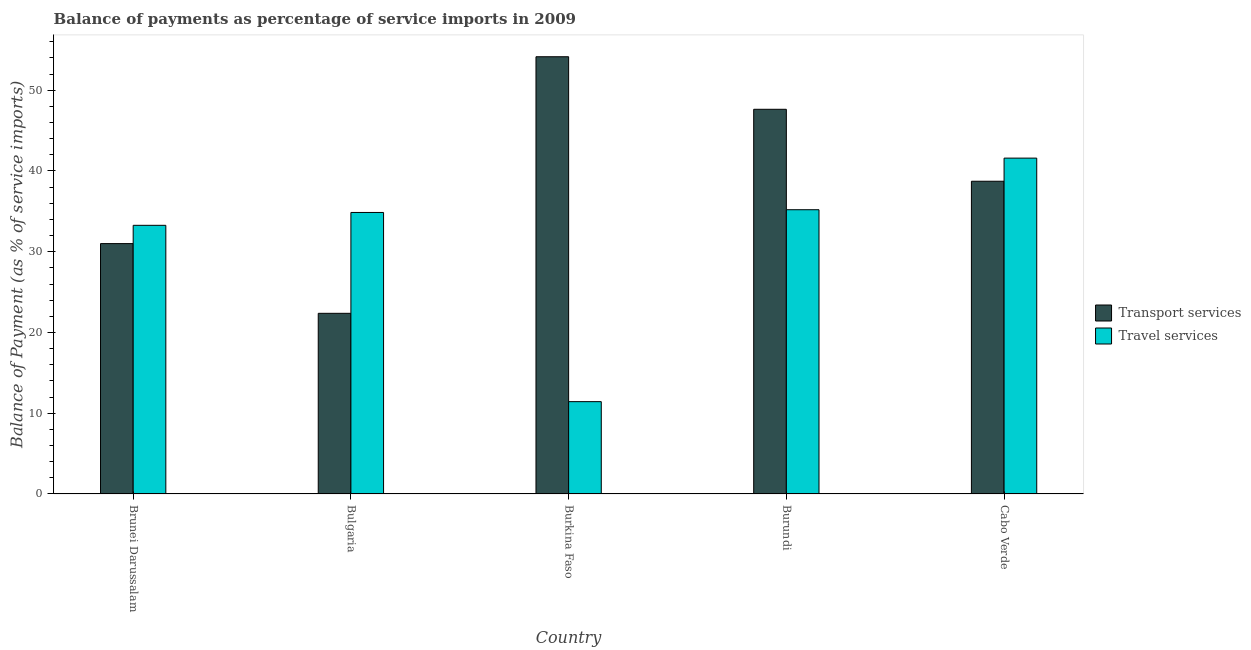How many different coloured bars are there?
Keep it short and to the point. 2. What is the label of the 1st group of bars from the left?
Ensure brevity in your answer.  Brunei Darussalam. In how many cases, is the number of bars for a given country not equal to the number of legend labels?
Provide a succinct answer. 0. What is the balance of payments of travel services in Bulgaria?
Your response must be concise. 34.86. Across all countries, what is the maximum balance of payments of travel services?
Provide a succinct answer. 41.59. Across all countries, what is the minimum balance of payments of transport services?
Keep it short and to the point. 22.37. In which country was the balance of payments of travel services maximum?
Your answer should be compact. Cabo Verde. In which country was the balance of payments of travel services minimum?
Offer a terse response. Burkina Faso. What is the total balance of payments of travel services in the graph?
Provide a succinct answer. 156.35. What is the difference between the balance of payments of travel services in Bulgaria and that in Burkina Faso?
Keep it short and to the point. 23.43. What is the difference between the balance of payments of travel services in Brunei Darussalam and the balance of payments of transport services in Burundi?
Offer a terse response. -14.37. What is the average balance of payments of travel services per country?
Keep it short and to the point. 31.27. What is the difference between the balance of payments of travel services and balance of payments of transport services in Burundi?
Make the answer very short. -12.44. In how many countries, is the balance of payments of transport services greater than 40 %?
Make the answer very short. 2. What is the ratio of the balance of payments of travel services in Bulgaria to that in Burkina Faso?
Ensure brevity in your answer.  3.05. Is the balance of payments of transport services in Burkina Faso less than that in Burundi?
Provide a succinct answer. No. Is the difference between the balance of payments of transport services in Bulgaria and Burkina Faso greater than the difference between the balance of payments of travel services in Bulgaria and Burkina Faso?
Your answer should be very brief. No. What is the difference between the highest and the second highest balance of payments of travel services?
Ensure brevity in your answer.  6.39. What is the difference between the highest and the lowest balance of payments of transport services?
Make the answer very short. 31.77. What does the 1st bar from the left in Burundi represents?
Make the answer very short. Transport services. What does the 1st bar from the right in Cabo Verde represents?
Provide a short and direct response. Travel services. Are all the bars in the graph horizontal?
Offer a terse response. No. Does the graph contain grids?
Your answer should be compact. No. Where does the legend appear in the graph?
Make the answer very short. Center right. What is the title of the graph?
Your answer should be compact. Balance of payments as percentage of service imports in 2009. Does "Transport services" appear as one of the legend labels in the graph?
Give a very brief answer. Yes. What is the label or title of the X-axis?
Provide a succinct answer. Country. What is the label or title of the Y-axis?
Keep it short and to the point. Balance of Payment (as % of service imports). What is the Balance of Payment (as % of service imports) in Transport services in Brunei Darussalam?
Give a very brief answer. 31. What is the Balance of Payment (as % of service imports) in Travel services in Brunei Darussalam?
Your answer should be compact. 33.27. What is the Balance of Payment (as % of service imports) in Transport services in Bulgaria?
Give a very brief answer. 22.37. What is the Balance of Payment (as % of service imports) of Travel services in Bulgaria?
Give a very brief answer. 34.86. What is the Balance of Payment (as % of service imports) of Transport services in Burkina Faso?
Your answer should be compact. 54.15. What is the Balance of Payment (as % of service imports) in Travel services in Burkina Faso?
Make the answer very short. 11.43. What is the Balance of Payment (as % of service imports) in Transport services in Burundi?
Keep it short and to the point. 47.64. What is the Balance of Payment (as % of service imports) in Travel services in Burundi?
Offer a very short reply. 35.2. What is the Balance of Payment (as % of service imports) of Transport services in Cabo Verde?
Ensure brevity in your answer.  38.73. What is the Balance of Payment (as % of service imports) in Travel services in Cabo Verde?
Your answer should be very brief. 41.59. Across all countries, what is the maximum Balance of Payment (as % of service imports) of Transport services?
Provide a succinct answer. 54.15. Across all countries, what is the maximum Balance of Payment (as % of service imports) in Travel services?
Provide a succinct answer. 41.59. Across all countries, what is the minimum Balance of Payment (as % of service imports) in Transport services?
Offer a very short reply. 22.37. Across all countries, what is the minimum Balance of Payment (as % of service imports) of Travel services?
Your answer should be very brief. 11.43. What is the total Balance of Payment (as % of service imports) in Transport services in the graph?
Offer a terse response. 193.89. What is the total Balance of Payment (as % of service imports) in Travel services in the graph?
Provide a succinct answer. 156.35. What is the difference between the Balance of Payment (as % of service imports) of Transport services in Brunei Darussalam and that in Bulgaria?
Offer a very short reply. 8.63. What is the difference between the Balance of Payment (as % of service imports) of Travel services in Brunei Darussalam and that in Bulgaria?
Provide a succinct answer. -1.59. What is the difference between the Balance of Payment (as % of service imports) of Transport services in Brunei Darussalam and that in Burkina Faso?
Provide a short and direct response. -23.14. What is the difference between the Balance of Payment (as % of service imports) in Travel services in Brunei Darussalam and that in Burkina Faso?
Provide a short and direct response. 21.83. What is the difference between the Balance of Payment (as % of service imports) in Transport services in Brunei Darussalam and that in Burundi?
Keep it short and to the point. -16.63. What is the difference between the Balance of Payment (as % of service imports) in Travel services in Brunei Darussalam and that in Burundi?
Your answer should be very brief. -1.93. What is the difference between the Balance of Payment (as % of service imports) in Transport services in Brunei Darussalam and that in Cabo Verde?
Your answer should be very brief. -7.72. What is the difference between the Balance of Payment (as % of service imports) of Travel services in Brunei Darussalam and that in Cabo Verde?
Your answer should be compact. -8.32. What is the difference between the Balance of Payment (as % of service imports) of Transport services in Bulgaria and that in Burkina Faso?
Your answer should be very brief. -31.77. What is the difference between the Balance of Payment (as % of service imports) of Travel services in Bulgaria and that in Burkina Faso?
Keep it short and to the point. 23.43. What is the difference between the Balance of Payment (as % of service imports) in Transport services in Bulgaria and that in Burundi?
Your answer should be very brief. -25.27. What is the difference between the Balance of Payment (as % of service imports) of Travel services in Bulgaria and that in Burundi?
Offer a very short reply. -0.34. What is the difference between the Balance of Payment (as % of service imports) of Transport services in Bulgaria and that in Cabo Verde?
Provide a short and direct response. -16.36. What is the difference between the Balance of Payment (as % of service imports) in Travel services in Bulgaria and that in Cabo Verde?
Make the answer very short. -6.73. What is the difference between the Balance of Payment (as % of service imports) in Transport services in Burkina Faso and that in Burundi?
Offer a very short reply. 6.51. What is the difference between the Balance of Payment (as % of service imports) of Travel services in Burkina Faso and that in Burundi?
Provide a succinct answer. -23.77. What is the difference between the Balance of Payment (as % of service imports) of Transport services in Burkina Faso and that in Cabo Verde?
Your response must be concise. 15.42. What is the difference between the Balance of Payment (as % of service imports) in Travel services in Burkina Faso and that in Cabo Verde?
Offer a very short reply. -30.16. What is the difference between the Balance of Payment (as % of service imports) of Transport services in Burundi and that in Cabo Verde?
Make the answer very short. 8.91. What is the difference between the Balance of Payment (as % of service imports) of Travel services in Burundi and that in Cabo Verde?
Keep it short and to the point. -6.39. What is the difference between the Balance of Payment (as % of service imports) in Transport services in Brunei Darussalam and the Balance of Payment (as % of service imports) in Travel services in Bulgaria?
Your response must be concise. -3.86. What is the difference between the Balance of Payment (as % of service imports) of Transport services in Brunei Darussalam and the Balance of Payment (as % of service imports) of Travel services in Burkina Faso?
Your response must be concise. 19.57. What is the difference between the Balance of Payment (as % of service imports) of Transport services in Brunei Darussalam and the Balance of Payment (as % of service imports) of Travel services in Burundi?
Your response must be concise. -4.2. What is the difference between the Balance of Payment (as % of service imports) of Transport services in Brunei Darussalam and the Balance of Payment (as % of service imports) of Travel services in Cabo Verde?
Give a very brief answer. -10.59. What is the difference between the Balance of Payment (as % of service imports) of Transport services in Bulgaria and the Balance of Payment (as % of service imports) of Travel services in Burkina Faso?
Provide a short and direct response. 10.94. What is the difference between the Balance of Payment (as % of service imports) in Transport services in Bulgaria and the Balance of Payment (as % of service imports) in Travel services in Burundi?
Offer a terse response. -12.83. What is the difference between the Balance of Payment (as % of service imports) of Transport services in Bulgaria and the Balance of Payment (as % of service imports) of Travel services in Cabo Verde?
Give a very brief answer. -19.22. What is the difference between the Balance of Payment (as % of service imports) of Transport services in Burkina Faso and the Balance of Payment (as % of service imports) of Travel services in Burundi?
Keep it short and to the point. 18.95. What is the difference between the Balance of Payment (as % of service imports) in Transport services in Burkina Faso and the Balance of Payment (as % of service imports) in Travel services in Cabo Verde?
Your response must be concise. 12.56. What is the difference between the Balance of Payment (as % of service imports) in Transport services in Burundi and the Balance of Payment (as % of service imports) in Travel services in Cabo Verde?
Your answer should be compact. 6.05. What is the average Balance of Payment (as % of service imports) of Transport services per country?
Offer a terse response. 38.78. What is the average Balance of Payment (as % of service imports) of Travel services per country?
Keep it short and to the point. 31.27. What is the difference between the Balance of Payment (as % of service imports) of Transport services and Balance of Payment (as % of service imports) of Travel services in Brunei Darussalam?
Provide a succinct answer. -2.26. What is the difference between the Balance of Payment (as % of service imports) in Transport services and Balance of Payment (as % of service imports) in Travel services in Bulgaria?
Keep it short and to the point. -12.49. What is the difference between the Balance of Payment (as % of service imports) in Transport services and Balance of Payment (as % of service imports) in Travel services in Burkina Faso?
Make the answer very short. 42.71. What is the difference between the Balance of Payment (as % of service imports) in Transport services and Balance of Payment (as % of service imports) in Travel services in Burundi?
Your response must be concise. 12.44. What is the difference between the Balance of Payment (as % of service imports) of Transport services and Balance of Payment (as % of service imports) of Travel services in Cabo Verde?
Your answer should be very brief. -2.86. What is the ratio of the Balance of Payment (as % of service imports) of Transport services in Brunei Darussalam to that in Bulgaria?
Give a very brief answer. 1.39. What is the ratio of the Balance of Payment (as % of service imports) of Travel services in Brunei Darussalam to that in Bulgaria?
Offer a very short reply. 0.95. What is the ratio of the Balance of Payment (as % of service imports) of Transport services in Brunei Darussalam to that in Burkina Faso?
Give a very brief answer. 0.57. What is the ratio of the Balance of Payment (as % of service imports) of Travel services in Brunei Darussalam to that in Burkina Faso?
Your answer should be compact. 2.91. What is the ratio of the Balance of Payment (as % of service imports) of Transport services in Brunei Darussalam to that in Burundi?
Your answer should be very brief. 0.65. What is the ratio of the Balance of Payment (as % of service imports) of Travel services in Brunei Darussalam to that in Burundi?
Your answer should be very brief. 0.95. What is the ratio of the Balance of Payment (as % of service imports) of Transport services in Brunei Darussalam to that in Cabo Verde?
Offer a very short reply. 0.8. What is the ratio of the Balance of Payment (as % of service imports) in Travel services in Brunei Darussalam to that in Cabo Verde?
Offer a terse response. 0.8. What is the ratio of the Balance of Payment (as % of service imports) in Transport services in Bulgaria to that in Burkina Faso?
Your answer should be very brief. 0.41. What is the ratio of the Balance of Payment (as % of service imports) of Travel services in Bulgaria to that in Burkina Faso?
Your answer should be compact. 3.05. What is the ratio of the Balance of Payment (as % of service imports) in Transport services in Bulgaria to that in Burundi?
Ensure brevity in your answer.  0.47. What is the ratio of the Balance of Payment (as % of service imports) of Travel services in Bulgaria to that in Burundi?
Ensure brevity in your answer.  0.99. What is the ratio of the Balance of Payment (as % of service imports) of Transport services in Bulgaria to that in Cabo Verde?
Offer a terse response. 0.58. What is the ratio of the Balance of Payment (as % of service imports) in Travel services in Bulgaria to that in Cabo Verde?
Keep it short and to the point. 0.84. What is the ratio of the Balance of Payment (as % of service imports) in Transport services in Burkina Faso to that in Burundi?
Offer a terse response. 1.14. What is the ratio of the Balance of Payment (as % of service imports) of Travel services in Burkina Faso to that in Burundi?
Offer a very short reply. 0.32. What is the ratio of the Balance of Payment (as % of service imports) in Transport services in Burkina Faso to that in Cabo Verde?
Your answer should be compact. 1.4. What is the ratio of the Balance of Payment (as % of service imports) in Travel services in Burkina Faso to that in Cabo Verde?
Provide a short and direct response. 0.27. What is the ratio of the Balance of Payment (as % of service imports) of Transport services in Burundi to that in Cabo Verde?
Keep it short and to the point. 1.23. What is the ratio of the Balance of Payment (as % of service imports) in Travel services in Burundi to that in Cabo Verde?
Provide a succinct answer. 0.85. What is the difference between the highest and the second highest Balance of Payment (as % of service imports) in Transport services?
Ensure brevity in your answer.  6.51. What is the difference between the highest and the second highest Balance of Payment (as % of service imports) in Travel services?
Your answer should be compact. 6.39. What is the difference between the highest and the lowest Balance of Payment (as % of service imports) in Transport services?
Your answer should be very brief. 31.77. What is the difference between the highest and the lowest Balance of Payment (as % of service imports) of Travel services?
Offer a terse response. 30.16. 